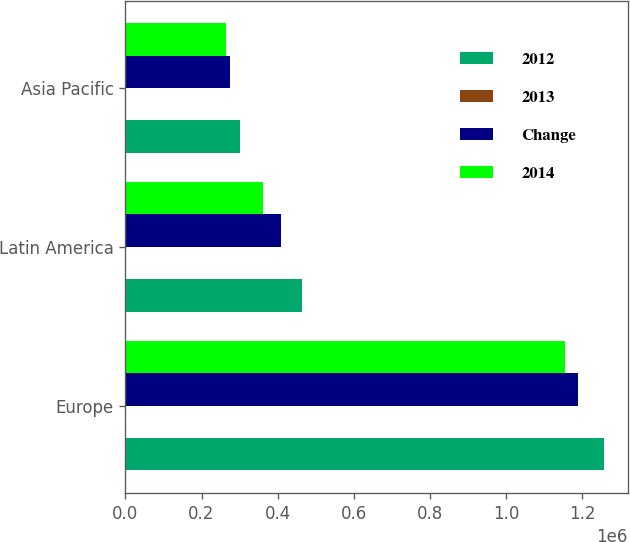Convert chart to OTSL. <chart><loc_0><loc_0><loc_500><loc_500><stacked_bar_chart><ecel><fcel>Europe<fcel>Latin America<fcel>Asia Pacific<nl><fcel>2012<fcel>1.25808e+06<fcel>463512<fcel>301407<nl><fcel>2013<fcel>6<fcel>14<fcel>10<nl><fcel>Change<fcel>1.19035e+06<fcel>407710<fcel>274920<nl><fcel>2014<fcel>1.15431e+06<fcel>362689<fcel>265120<nl></chart> 